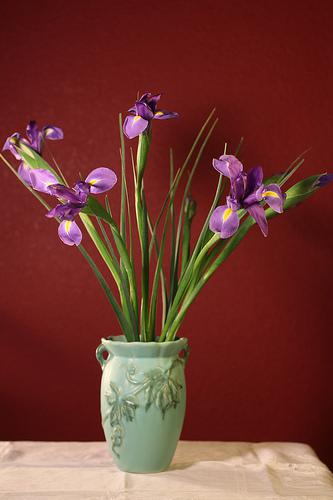Question: what color are the flowers?
Choices:
A. Blue.
B. Red.
C. White.
D. Purple.
Answer with the letter. Answer: D Question: how many vases are there?
Choices:
A. Two.
B. One.
C. Three.
D. Six.
Answer with the letter. Answer: B Question: where is the vase located?
Choices:
A. My desk.
B. On a table.
C. A chair.
D. The floor.
Answer with the letter. Answer: B Question: what color is the vase?
Choices:
A. Green.
B. Blue.
C. Purple.
D. Clear.
Answer with the letter. Answer: A Question: what color is the wall?
Choices:
A. Red.
B. Green.
C. Yellow.
D. White.
Answer with the letter. Answer: A 